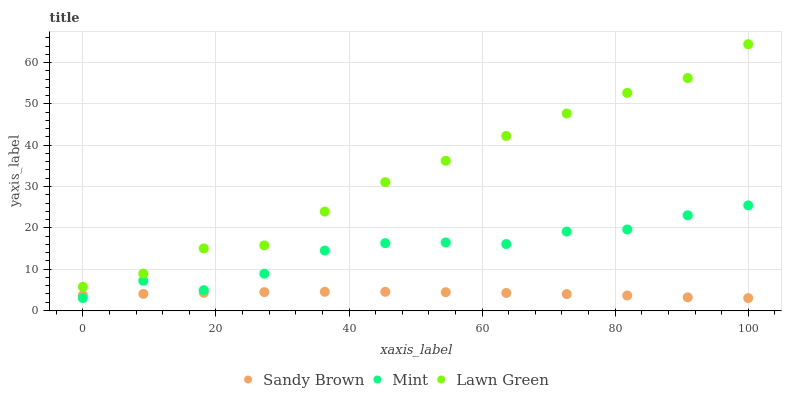Does Sandy Brown have the minimum area under the curve?
Answer yes or no. Yes. Does Lawn Green have the maximum area under the curve?
Answer yes or no. Yes. Does Lawn Green have the minimum area under the curve?
Answer yes or no. No. Does Sandy Brown have the maximum area under the curve?
Answer yes or no. No. Is Sandy Brown the smoothest?
Answer yes or no. Yes. Is Mint the roughest?
Answer yes or no. Yes. Is Lawn Green the smoothest?
Answer yes or no. No. Is Lawn Green the roughest?
Answer yes or no. No. Does Mint have the lowest value?
Answer yes or no. Yes. Does Lawn Green have the lowest value?
Answer yes or no. No. Does Lawn Green have the highest value?
Answer yes or no. Yes. Does Sandy Brown have the highest value?
Answer yes or no. No. Is Sandy Brown less than Lawn Green?
Answer yes or no. Yes. Is Lawn Green greater than Mint?
Answer yes or no. Yes. Does Mint intersect Sandy Brown?
Answer yes or no. Yes. Is Mint less than Sandy Brown?
Answer yes or no. No. Is Mint greater than Sandy Brown?
Answer yes or no. No. Does Sandy Brown intersect Lawn Green?
Answer yes or no. No. 